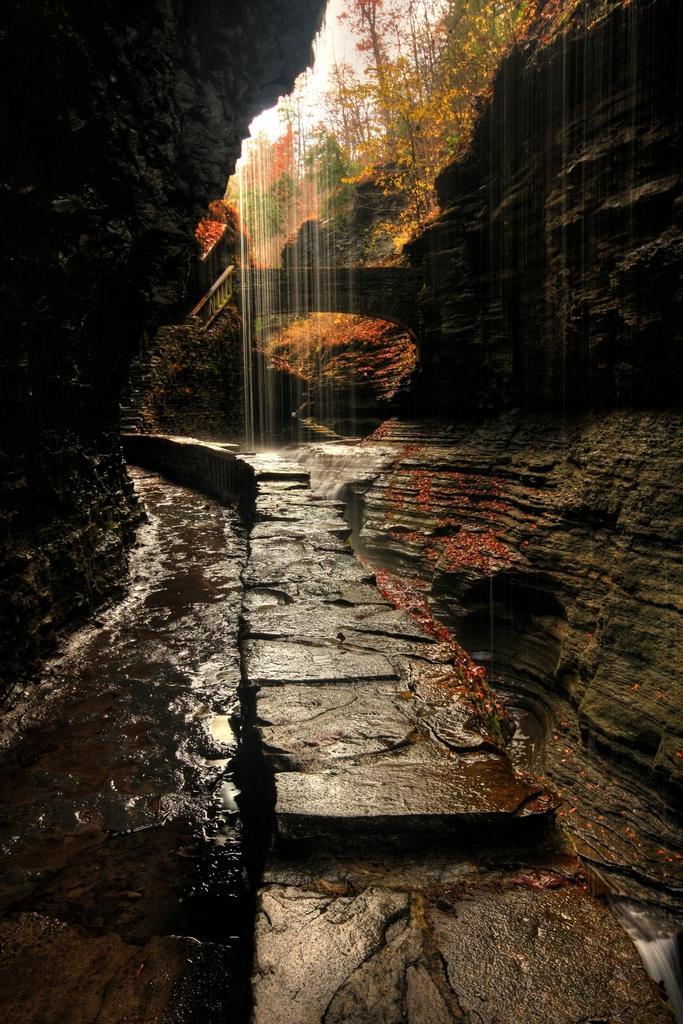In one or two sentences, can you explain what this image depicts? In this image there is a waterfall on the rocks. In the background of the image there are trees and sky. 